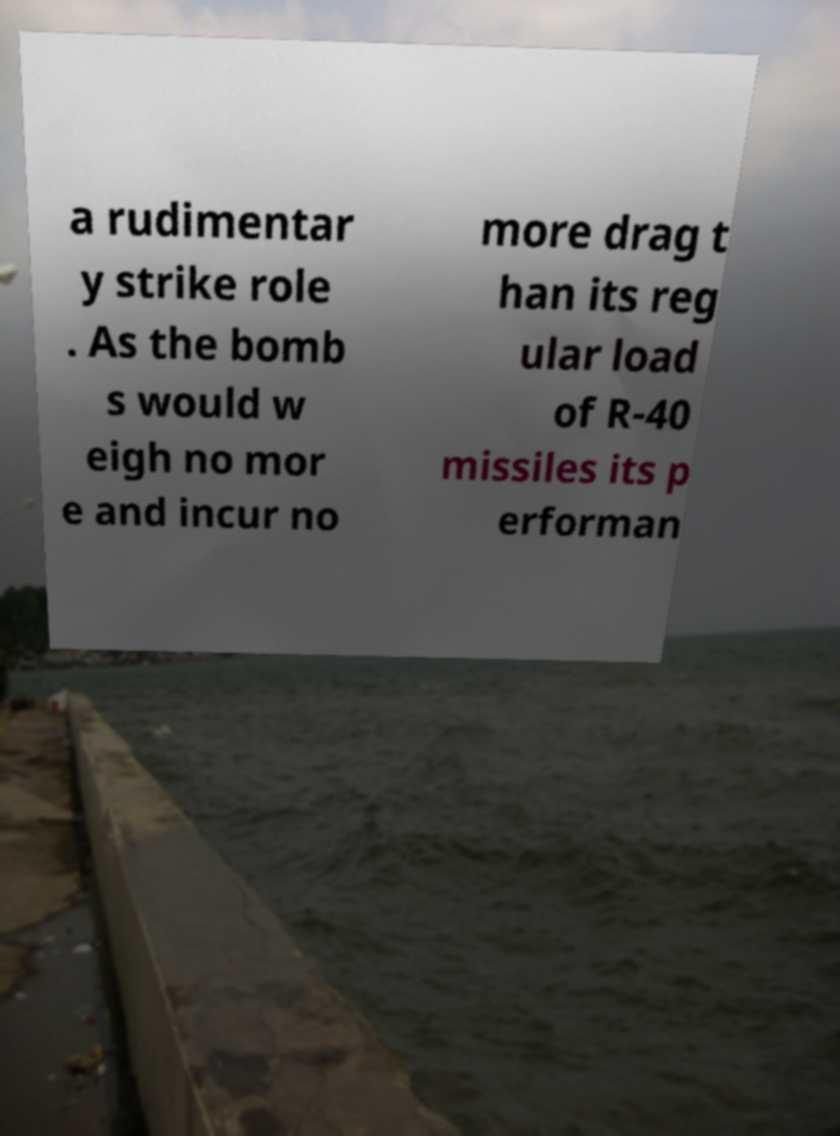Please identify and transcribe the text found in this image. a rudimentar y strike role . As the bomb s would w eigh no mor e and incur no more drag t han its reg ular load of R-40 missiles its p erforman 